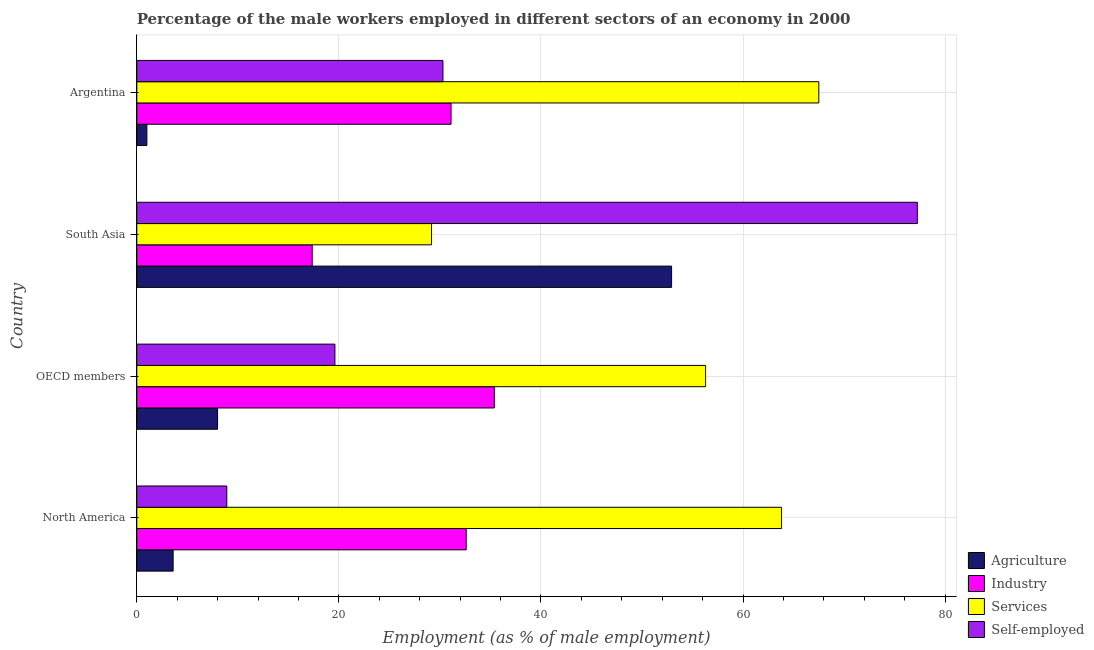How many groups of bars are there?
Your response must be concise. 4. How many bars are there on the 4th tick from the top?
Your answer should be very brief. 4. How many bars are there on the 2nd tick from the bottom?
Offer a terse response. 4. In how many cases, is the number of bars for a given country not equal to the number of legend labels?
Your answer should be very brief. 0. What is the percentage of self employed male workers in OECD members?
Your answer should be very brief. 19.61. Across all countries, what is the maximum percentage of self employed male workers?
Make the answer very short. 77.25. Across all countries, what is the minimum percentage of male workers in agriculture?
Ensure brevity in your answer.  1. In which country was the percentage of male workers in services minimum?
Make the answer very short. South Asia. What is the total percentage of male workers in services in the graph?
Provide a short and direct response. 216.76. What is the difference between the percentage of male workers in services in Argentina and that in South Asia?
Your answer should be very brief. 38.33. What is the difference between the percentage of self employed male workers in OECD members and the percentage of male workers in agriculture in North America?
Ensure brevity in your answer.  16.01. What is the average percentage of male workers in agriculture per country?
Offer a terse response. 16.38. What is the difference between the percentage of male workers in services and percentage of self employed male workers in North America?
Give a very brief answer. 54.9. What is the ratio of the percentage of male workers in industry in Argentina to that in North America?
Your answer should be compact. 0.95. Is the percentage of male workers in services in North America less than that in OECD members?
Offer a terse response. No. Is the difference between the percentage of male workers in agriculture in Argentina and North America greater than the difference between the percentage of male workers in services in Argentina and North America?
Provide a short and direct response. No. What is the difference between the highest and the second highest percentage of self employed male workers?
Make the answer very short. 46.95. What is the difference between the highest and the lowest percentage of male workers in services?
Offer a very short reply. 38.33. In how many countries, is the percentage of male workers in agriculture greater than the average percentage of male workers in agriculture taken over all countries?
Your response must be concise. 1. Is the sum of the percentage of male workers in agriculture in Argentina and South Asia greater than the maximum percentage of male workers in services across all countries?
Your answer should be compact. No. What does the 1st bar from the top in South Asia represents?
Provide a short and direct response. Self-employed. What does the 1st bar from the bottom in Argentina represents?
Your answer should be compact. Agriculture. Is it the case that in every country, the sum of the percentage of male workers in agriculture and percentage of male workers in industry is greater than the percentage of male workers in services?
Your response must be concise. No. Are all the bars in the graph horizontal?
Offer a terse response. Yes. Does the graph contain any zero values?
Your answer should be compact. No. How are the legend labels stacked?
Offer a very short reply. Vertical. What is the title of the graph?
Your answer should be compact. Percentage of the male workers employed in different sectors of an economy in 2000. What is the label or title of the X-axis?
Offer a terse response. Employment (as % of male employment). What is the Employment (as % of male employment) of Agriculture in North America?
Give a very brief answer. 3.6. What is the Employment (as % of male employment) of Industry in North America?
Provide a short and direct response. 32.6. What is the Employment (as % of male employment) of Services in North America?
Give a very brief answer. 63.8. What is the Employment (as % of male employment) in Self-employed in North America?
Offer a terse response. 8.91. What is the Employment (as % of male employment) in Agriculture in OECD members?
Make the answer very short. 7.99. What is the Employment (as % of male employment) in Industry in OECD members?
Ensure brevity in your answer.  35.38. What is the Employment (as % of male employment) of Services in OECD members?
Make the answer very short. 56.29. What is the Employment (as % of male employment) of Self-employed in OECD members?
Ensure brevity in your answer.  19.61. What is the Employment (as % of male employment) in Agriculture in South Asia?
Your answer should be compact. 52.93. What is the Employment (as % of male employment) of Industry in South Asia?
Give a very brief answer. 17.36. What is the Employment (as % of male employment) in Services in South Asia?
Your answer should be very brief. 29.17. What is the Employment (as % of male employment) in Self-employed in South Asia?
Make the answer very short. 77.25. What is the Employment (as % of male employment) in Industry in Argentina?
Give a very brief answer. 31.1. What is the Employment (as % of male employment) of Services in Argentina?
Provide a short and direct response. 67.5. What is the Employment (as % of male employment) in Self-employed in Argentina?
Make the answer very short. 30.3. Across all countries, what is the maximum Employment (as % of male employment) in Agriculture?
Your response must be concise. 52.93. Across all countries, what is the maximum Employment (as % of male employment) of Industry?
Provide a short and direct response. 35.38. Across all countries, what is the maximum Employment (as % of male employment) in Services?
Offer a terse response. 67.5. Across all countries, what is the maximum Employment (as % of male employment) in Self-employed?
Your answer should be compact. 77.25. Across all countries, what is the minimum Employment (as % of male employment) of Agriculture?
Make the answer very short. 1. Across all countries, what is the minimum Employment (as % of male employment) in Industry?
Ensure brevity in your answer.  17.36. Across all countries, what is the minimum Employment (as % of male employment) of Services?
Your answer should be very brief. 29.17. Across all countries, what is the minimum Employment (as % of male employment) of Self-employed?
Your response must be concise. 8.91. What is the total Employment (as % of male employment) in Agriculture in the graph?
Provide a succinct answer. 65.52. What is the total Employment (as % of male employment) of Industry in the graph?
Keep it short and to the point. 116.44. What is the total Employment (as % of male employment) in Services in the graph?
Your response must be concise. 216.76. What is the total Employment (as % of male employment) of Self-employed in the graph?
Keep it short and to the point. 136.07. What is the difference between the Employment (as % of male employment) of Agriculture in North America and that in OECD members?
Your answer should be very brief. -4.4. What is the difference between the Employment (as % of male employment) of Industry in North America and that in OECD members?
Your response must be concise. -2.78. What is the difference between the Employment (as % of male employment) of Services in North America and that in OECD members?
Keep it short and to the point. 7.51. What is the difference between the Employment (as % of male employment) in Self-employed in North America and that in OECD members?
Provide a succinct answer. -10.7. What is the difference between the Employment (as % of male employment) in Agriculture in North America and that in South Asia?
Your answer should be compact. -49.33. What is the difference between the Employment (as % of male employment) in Industry in North America and that in South Asia?
Your answer should be compact. 15.24. What is the difference between the Employment (as % of male employment) of Services in North America and that in South Asia?
Make the answer very short. 34.64. What is the difference between the Employment (as % of male employment) in Self-employed in North America and that in South Asia?
Ensure brevity in your answer.  -68.35. What is the difference between the Employment (as % of male employment) of Agriculture in North America and that in Argentina?
Your response must be concise. 2.6. What is the difference between the Employment (as % of male employment) in Services in North America and that in Argentina?
Offer a very short reply. -3.7. What is the difference between the Employment (as % of male employment) of Self-employed in North America and that in Argentina?
Offer a very short reply. -21.39. What is the difference between the Employment (as % of male employment) of Agriculture in OECD members and that in South Asia?
Give a very brief answer. -44.93. What is the difference between the Employment (as % of male employment) in Industry in OECD members and that in South Asia?
Your answer should be compact. 18.02. What is the difference between the Employment (as % of male employment) in Services in OECD members and that in South Asia?
Your response must be concise. 27.13. What is the difference between the Employment (as % of male employment) of Self-employed in OECD members and that in South Asia?
Make the answer very short. -57.65. What is the difference between the Employment (as % of male employment) of Agriculture in OECD members and that in Argentina?
Provide a succinct answer. 6.99. What is the difference between the Employment (as % of male employment) in Industry in OECD members and that in Argentina?
Your response must be concise. 4.28. What is the difference between the Employment (as % of male employment) in Services in OECD members and that in Argentina?
Provide a short and direct response. -11.21. What is the difference between the Employment (as % of male employment) of Self-employed in OECD members and that in Argentina?
Keep it short and to the point. -10.69. What is the difference between the Employment (as % of male employment) in Agriculture in South Asia and that in Argentina?
Provide a succinct answer. 51.93. What is the difference between the Employment (as % of male employment) of Industry in South Asia and that in Argentina?
Offer a very short reply. -13.74. What is the difference between the Employment (as % of male employment) of Services in South Asia and that in Argentina?
Your response must be concise. -38.33. What is the difference between the Employment (as % of male employment) of Self-employed in South Asia and that in Argentina?
Offer a very short reply. 46.95. What is the difference between the Employment (as % of male employment) in Agriculture in North America and the Employment (as % of male employment) in Industry in OECD members?
Provide a succinct answer. -31.79. What is the difference between the Employment (as % of male employment) of Agriculture in North America and the Employment (as % of male employment) of Services in OECD members?
Keep it short and to the point. -52.7. What is the difference between the Employment (as % of male employment) in Agriculture in North America and the Employment (as % of male employment) in Self-employed in OECD members?
Your answer should be compact. -16.01. What is the difference between the Employment (as % of male employment) of Industry in North America and the Employment (as % of male employment) of Services in OECD members?
Keep it short and to the point. -23.69. What is the difference between the Employment (as % of male employment) of Industry in North America and the Employment (as % of male employment) of Self-employed in OECD members?
Make the answer very short. 12.99. What is the difference between the Employment (as % of male employment) in Services in North America and the Employment (as % of male employment) in Self-employed in OECD members?
Keep it short and to the point. 44.2. What is the difference between the Employment (as % of male employment) of Agriculture in North America and the Employment (as % of male employment) of Industry in South Asia?
Make the answer very short. -13.76. What is the difference between the Employment (as % of male employment) in Agriculture in North America and the Employment (as % of male employment) in Services in South Asia?
Provide a short and direct response. -25.57. What is the difference between the Employment (as % of male employment) of Agriculture in North America and the Employment (as % of male employment) of Self-employed in South Asia?
Your answer should be compact. -73.66. What is the difference between the Employment (as % of male employment) in Industry in North America and the Employment (as % of male employment) in Services in South Asia?
Your answer should be compact. 3.43. What is the difference between the Employment (as % of male employment) in Industry in North America and the Employment (as % of male employment) in Self-employed in South Asia?
Offer a terse response. -44.65. What is the difference between the Employment (as % of male employment) in Services in North America and the Employment (as % of male employment) in Self-employed in South Asia?
Your response must be concise. -13.45. What is the difference between the Employment (as % of male employment) of Agriculture in North America and the Employment (as % of male employment) of Industry in Argentina?
Keep it short and to the point. -27.5. What is the difference between the Employment (as % of male employment) in Agriculture in North America and the Employment (as % of male employment) in Services in Argentina?
Provide a short and direct response. -63.9. What is the difference between the Employment (as % of male employment) of Agriculture in North America and the Employment (as % of male employment) of Self-employed in Argentina?
Your answer should be compact. -26.7. What is the difference between the Employment (as % of male employment) of Industry in North America and the Employment (as % of male employment) of Services in Argentina?
Provide a succinct answer. -34.9. What is the difference between the Employment (as % of male employment) of Industry in North America and the Employment (as % of male employment) of Self-employed in Argentina?
Offer a terse response. 2.3. What is the difference between the Employment (as % of male employment) in Services in North America and the Employment (as % of male employment) in Self-employed in Argentina?
Make the answer very short. 33.5. What is the difference between the Employment (as % of male employment) of Agriculture in OECD members and the Employment (as % of male employment) of Industry in South Asia?
Your answer should be compact. -9.36. What is the difference between the Employment (as % of male employment) in Agriculture in OECD members and the Employment (as % of male employment) in Services in South Asia?
Your response must be concise. -21.17. What is the difference between the Employment (as % of male employment) in Agriculture in OECD members and the Employment (as % of male employment) in Self-employed in South Asia?
Your answer should be very brief. -69.26. What is the difference between the Employment (as % of male employment) of Industry in OECD members and the Employment (as % of male employment) of Services in South Asia?
Give a very brief answer. 6.21. What is the difference between the Employment (as % of male employment) in Industry in OECD members and the Employment (as % of male employment) in Self-employed in South Asia?
Give a very brief answer. -41.87. What is the difference between the Employment (as % of male employment) in Services in OECD members and the Employment (as % of male employment) in Self-employed in South Asia?
Your response must be concise. -20.96. What is the difference between the Employment (as % of male employment) of Agriculture in OECD members and the Employment (as % of male employment) of Industry in Argentina?
Ensure brevity in your answer.  -23.11. What is the difference between the Employment (as % of male employment) of Agriculture in OECD members and the Employment (as % of male employment) of Services in Argentina?
Ensure brevity in your answer.  -59.51. What is the difference between the Employment (as % of male employment) in Agriculture in OECD members and the Employment (as % of male employment) in Self-employed in Argentina?
Provide a short and direct response. -22.31. What is the difference between the Employment (as % of male employment) in Industry in OECD members and the Employment (as % of male employment) in Services in Argentina?
Ensure brevity in your answer.  -32.12. What is the difference between the Employment (as % of male employment) in Industry in OECD members and the Employment (as % of male employment) in Self-employed in Argentina?
Give a very brief answer. 5.08. What is the difference between the Employment (as % of male employment) of Services in OECD members and the Employment (as % of male employment) of Self-employed in Argentina?
Keep it short and to the point. 25.99. What is the difference between the Employment (as % of male employment) of Agriculture in South Asia and the Employment (as % of male employment) of Industry in Argentina?
Keep it short and to the point. 21.83. What is the difference between the Employment (as % of male employment) in Agriculture in South Asia and the Employment (as % of male employment) in Services in Argentina?
Offer a very short reply. -14.57. What is the difference between the Employment (as % of male employment) in Agriculture in South Asia and the Employment (as % of male employment) in Self-employed in Argentina?
Ensure brevity in your answer.  22.63. What is the difference between the Employment (as % of male employment) in Industry in South Asia and the Employment (as % of male employment) in Services in Argentina?
Offer a terse response. -50.14. What is the difference between the Employment (as % of male employment) of Industry in South Asia and the Employment (as % of male employment) of Self-employed in Argentina?
Your answer should be compact. -12.94. What is the difference between the Employment (as % of male employment) in Services in South Asia and the Employment (as % of male employment) in Self-employed in Argentina?
Keep it short and to the point. -1.13. What is the average Employment (as % of male employment) of Agriculture per country?
Provide a succinct answer. 16.38. What is the average Employment (as % of male employment) of Industry per country?
Your answer should be compact. 29.11. What is the average Employment (as % of male employment) in Services per country?
Your response must be concise. 54.19. What is the average Employment (as % of male employment) of Self-employed per country?
Your response must be concise. 34.02. What is the difference between the Employment (as % of male employment) in Agriculture and Employment (as % of male employment) in Industry in North America?
Your answer should be very brief. -29. What is the difference between the Employment (as % of male employment) of Agriculture and Employment (as % of male employment) of Services in North America?
Your answer should be very brief. -60.21. What is the difference between the Employment (as % of male employment) of Agriculture and Employment (as % of male employment) of Self-employed in North America?
Your answer should be very brief. -5.31. What is the difference between the Employment (as % of male employment) in Industry and Employment (as % of male employment) in Services in North America?
Your answer should be very brief. -31.2. What is the difference between the Employment (as % of male employment) in Industry and Employment (as % of male employment) in Self-employed in North America?
Provide a short and direct response. 23.69. What is the difference between the Employment (as % of male employment) in Services and Employment (as % of male employment) in Self-employed in North America?
Offer a very short reply. 54.9. What is the difference between the Employment (as % of male employment) in Agriculture and Employment (as % of male employment) in Industry in OECD members?
Provide a short and direct response. -27.39. What is the difference between the Employment (as % of male employment) in Agriculture and Employment (as % of male employment) in Services in OECD members?
Your response must be concise. -48.3. What is the difference between the Employment (as % of male employment) of Agriculture and Employment (as % of male employment) of Self-employed in OECD members?
Ensure brevity in your answer.  -11.61. What is the difference between the Employment (as % of male employment) of Industry and Employment (as % of male employment) of Services in OECD members?
Provide a short and direct response. -20.91. What is the difference between the Employment (as % of male employment) of Industry and Employment (as % of male employment) of Self-employed in OECD members?
Your response must be concise. 15.77. What is the difference between the Employment (as % of male employment) of Services and Employment (as % of male employment) of Self-employed in OECD members?
Make the answer very short. 36.69. What is the difference between the Employment (as % of male employment) in Agriculture and Employment (as % of male employment) in Industry in South Asia?
Provide a short and direct response. 35.57. What is the difference between the Employment (as % of male employment) of Agriculture and Employment (as % of male employment) of Services in South Asia?
Offer a very short reply. 23.76. What is the difference between the Employment (as % of male employment) in Agriculture and Employment (as % of male employment) in Self-employed in South Asia?
Give a very brief answer. -24.32. What is the difference between the Employment (as % of male employment) of Industry and Employment (as % of male employment) of Services in South Asia?
Provide a short and direct response. -11.81. What is the difference between the Employment (as % of male employment) in Industry and Employment (as % of male employment) in Self-employed in South Asia?
Give a very brief answer. -59.9. What is the difference between the Employment (as % of male employment) of Services and Employment (as % of male employment) of Self-employed in South Asia?
Your response must be concise. -48.09. What is the difference between the Employment (as % of male employment) of Agriculture and Employment (as % of male employment) of Industry in Argentina?
Provide a short and direct response. -30.1. What is the difference between the Employment (as % of male employment) in Agriculture and Employment (as % of male employment) in Services in Argentina?
Provide a succinct answer. -66.5. What is the difference between the Employment (as % of male employment) in Agriculture and Employment (as % of male employment) in Self-employed in Argentina?
Ensure brevity in your answer.  -29.3. What is the difference between the Employment (as % of male employment) in Industry and Employment (as % of male employment) in Services in Argentina?
Your answer should be compact. -36.4. What is the difference between the Employment (as % of male employment) of Industry and Employment (as % of male employment) of Self-employed in Argentina?
Offer a very short reply. 0.8. What is the difference between the Employment (as % of male employment) in Services and Employment (as % of male employment) in Self-employed in Argentina?
Your answer should be very brief. 37.2. What is the ratio of the Employment (as % of male employment) of Agriculture in North America to that in OECD members?
Your response must be concise. 0.45. What is the ratio of the Employment (as % of male employment) in Industry in North America to that in OECD members?
Offer a terse response. 0.92. What is the ratio of the Employment (as % of male employment) of Services in North America to that in OECD members?
Make the answer very short. 1.13. What is the ratio of the Employment (as % of male employment) in Self-employed in North America to that in OECD members?
Offer a very short reply. 0.45. What is the ratio of the Employment (as % of male employment) of Agriculture in North America to that in South Asia?
Provide a short and direct response. 0.07. What is the ratio of the Employment (as % of male employment) of Industry in North America to that in South Asia?
Provide a succinct answer. 1.88. What is the ratio of the Employment (as % of male employment) in Services in North America to that in South Asia?
Keep it short and to the point. 2.19. What is the ratio of the Employment (as % of male employment) of Self-employed in North America to that in South Asia?
Keep it short and to the point. 0.12. What is the ratio of the Employment (as % of male employment) in Agriculture in North America to that in Argentina?
Make the answer very short. 3.6. What is the ratio of the Employment (as % of male employment) of Industry in North America to that in Argentina?
Offer a very short reply. 1.05. What is the ratio of the Employment (as % of male employment) of Services in North America to that in Argentina?
Keep it short and to the point. 0.95. What is the ratio of the Employment (as % of male employment) of Self-employed in North America to that in Argentina?
Provide a succinct answer. 0.29. What is the ratio of the Employment (as % of male employment) of Agriculture in OECD members to that in South Asia?
Give a very brief answer. 0.15. What is the ratio of the Employment (as % of male employment) of Industry in OECD members to that in South Asia?
Give a very brief answer. 2.04. What is the ratio of the Employment (as % of male employment) of Services in OECD members to that in South Asia?
Ensure brevity in your answer.  1.93. What is the ratio of the Employment (as % of male employment) of Self-employed in OECD members to that in South Asia?
Keep it short and to the point. 0.25. What is the ratio of the Employment (as % of male employment) of Agriculture in OECD members to that in Argentina?
Your response must be concise. 7.99. What is the ratio of the Employment (as % of male employment) in Industry in OECD members to that in Argentina?
Keep it short and to the point. 1.14. What is the ratio of the Employment (as % of male employment) in Services in OECD members to that in Argentina?
Provide a short and direct response. 0.83. What is the ratio of the Employment (as % of male employment) of Self-employed in OECD members to that in Argentina?
Provide a succinct answer. 0.65. What is the ratio of the Employment (as % of male employment) in Agriculture in South Asia to that in Argentina?
Provide a short and direct response. 52.93. What is the ratio of the Employment (as % of male employment) in Industry in South Asia to that in Argentina?
Your answer should be very brief. 0.56. What is the ratio of the Employment (as % of male employment) of Services in South Asia to that in Argentina?
Offer a terse response. 0.43. What is the ratio of the Employment (as % of male employment) in Self-employed in South Asia to that in Argentina?
Make the answer very short. 2.55. What is the difference between the highest and the second highest Employment (as % of male employment) of Agriculture?
Provide a short and direct response. 44.93. What is the difference between the highest and the second highest Employment (as % of male employment) in Industry?
Offer a very short reply. 2.78. What is the difference between the highest and the second highest Employment (as % of male employment) in Services?
Your answer should be compact. 3.7. What is the difference between the highest and the second highest Employment (as % of male employment) of Self-employed?
Offer a terse response. 46.95. What is the difference between the highest and the lowest Employment (as % of male employment) of Agriculture?
Ensure brevity in your answer.  51.93. What is the difference between the highest and the lowest Employment (as % of male employment) in Industry?
Ensure brevity in your answer.  18.02. What is the difference between the highest and the lowest Employment (as % of male employment) of Services?
Give a very brief answer. 38.33. What is the difference between the highest and the lowest Employment (as % of male employment) in Self-employed?
Offer a terse response. 68.35. 